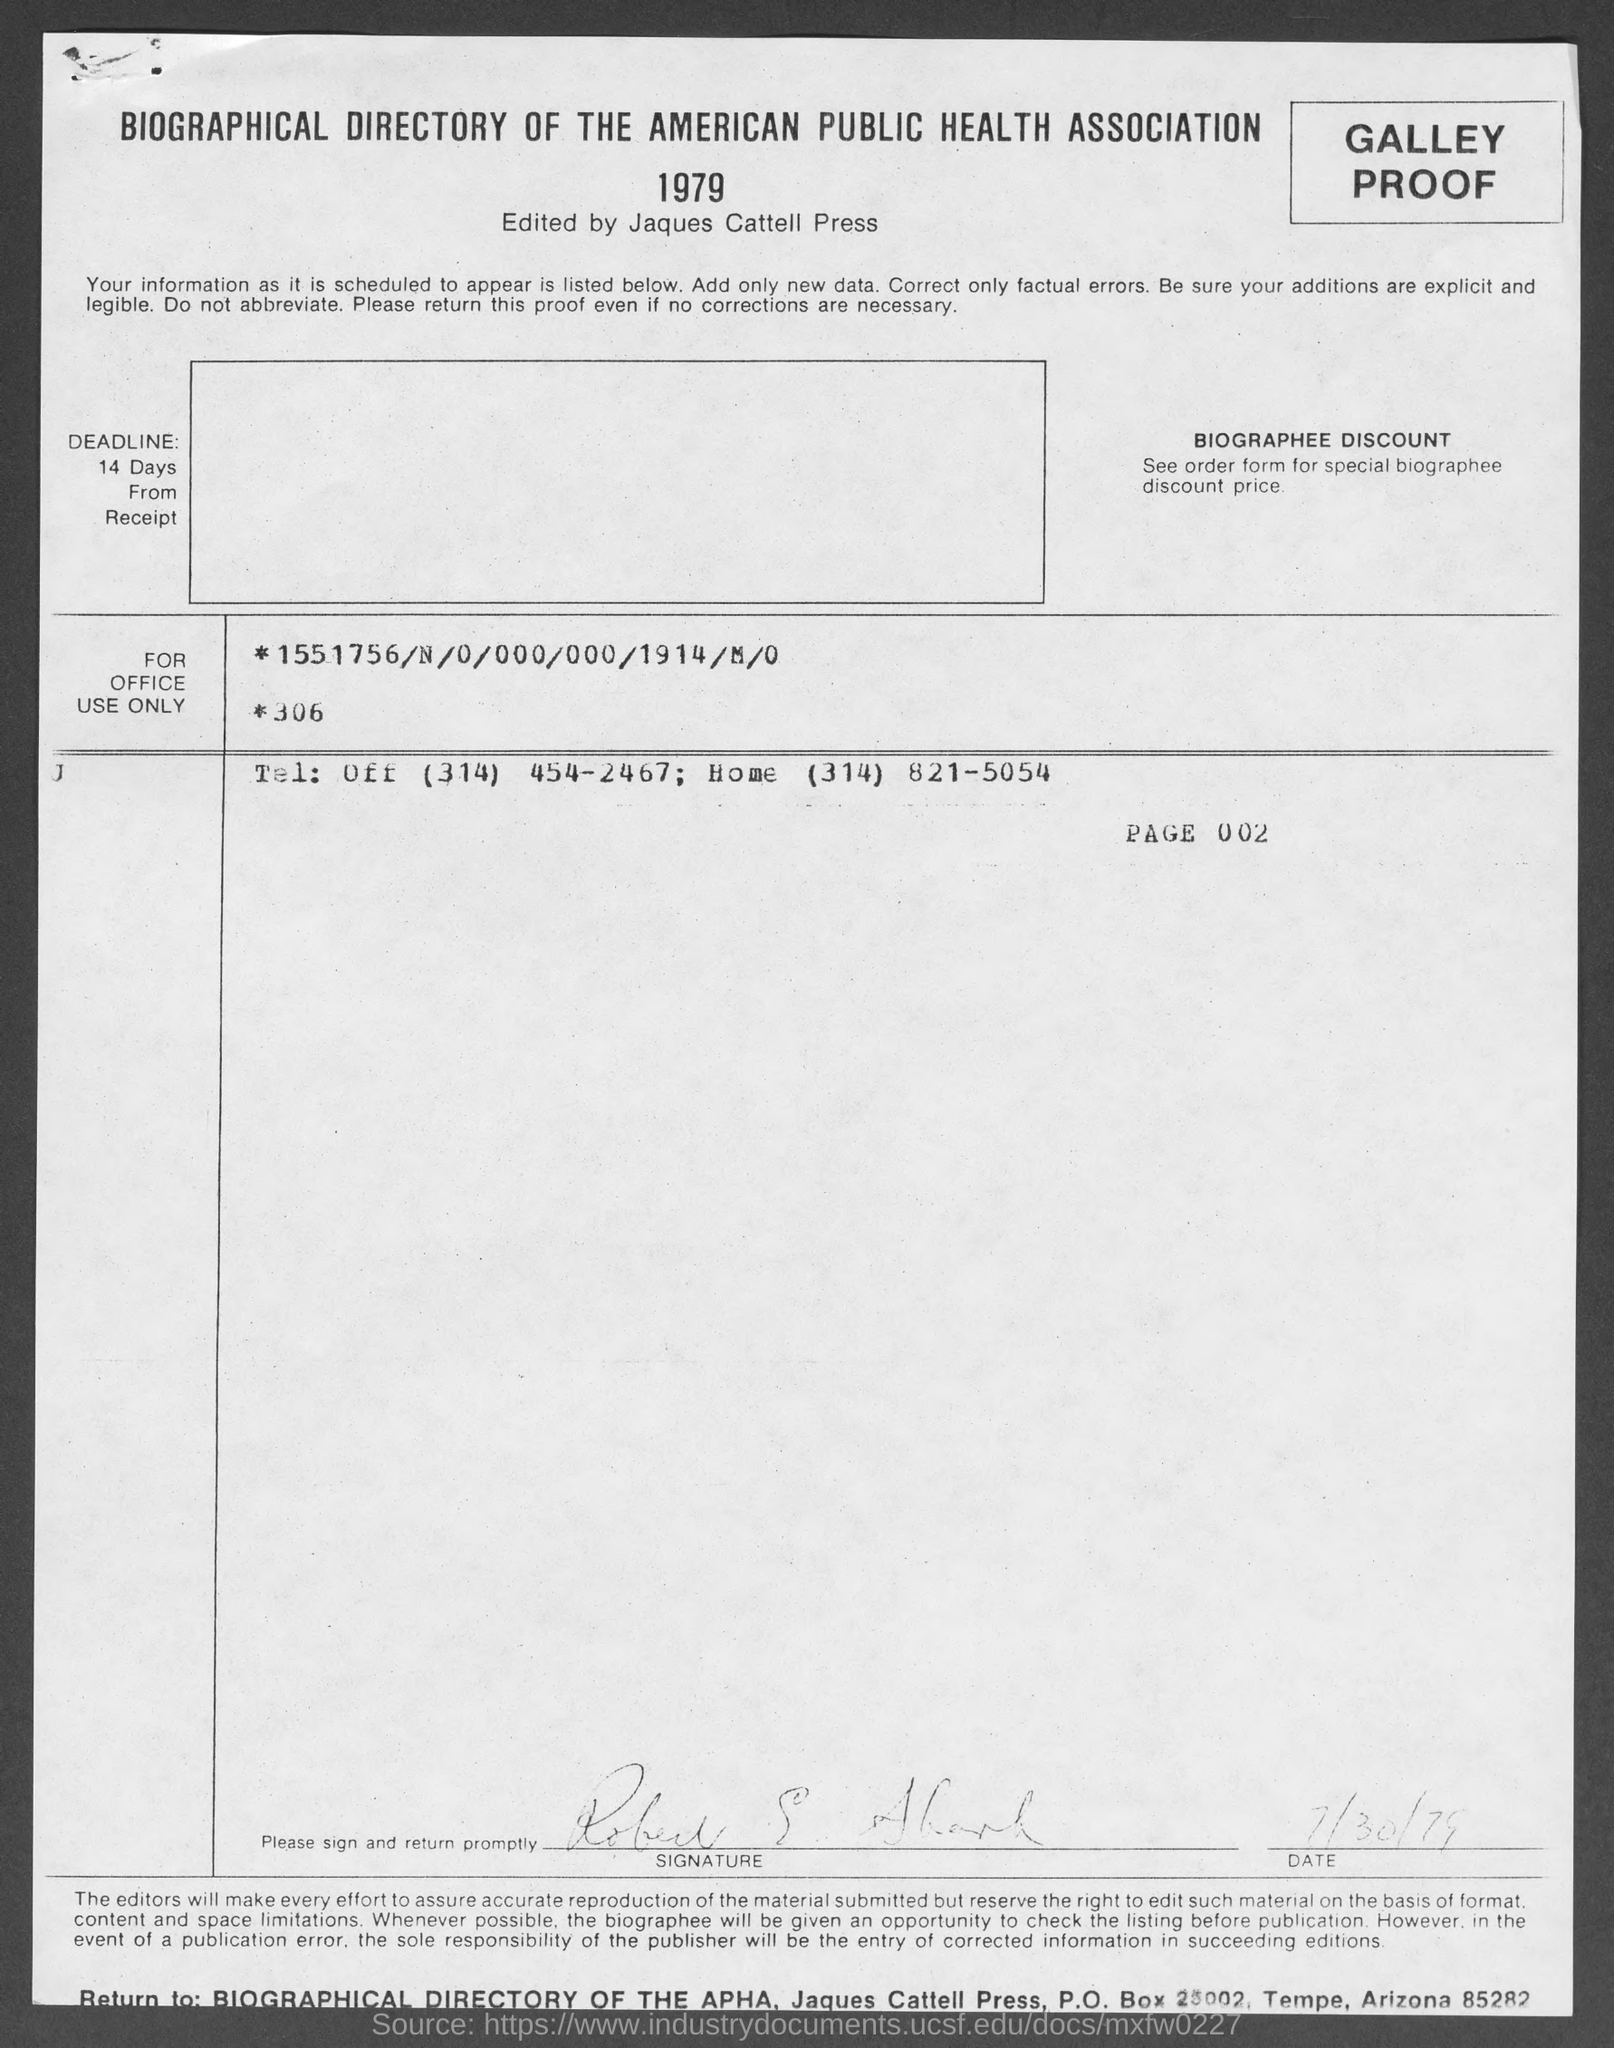What is the date mentioned in this document?
Offer a terse response. 7/30/79. 